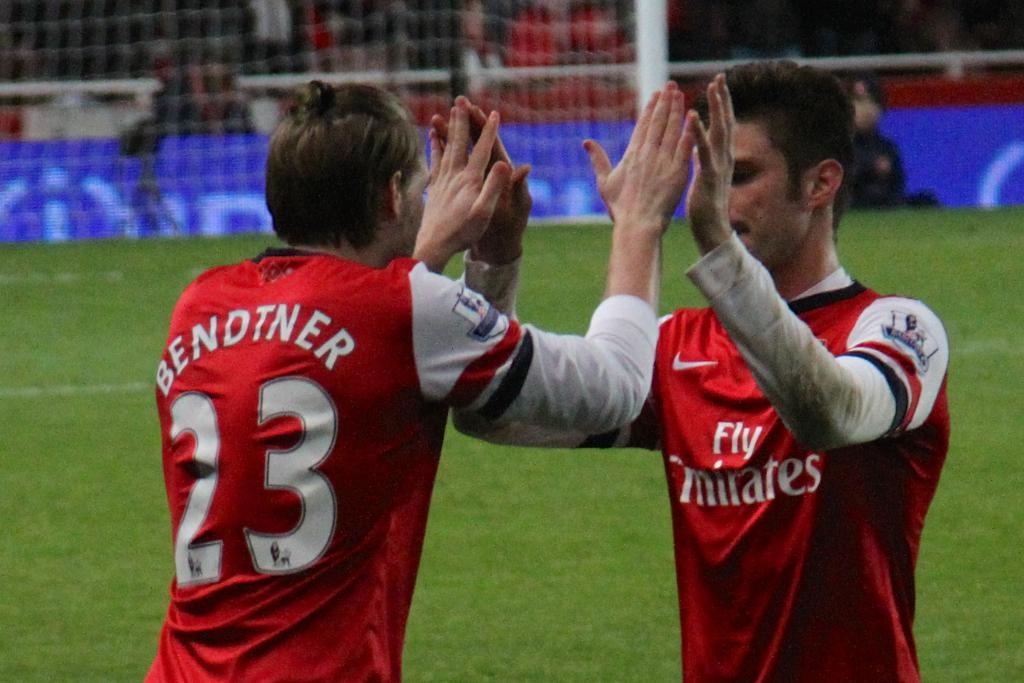<image>
Write a terse but informative summary of the picture. Two soccer players, one with the name BENDTNER and the number 23 on his jersey. 